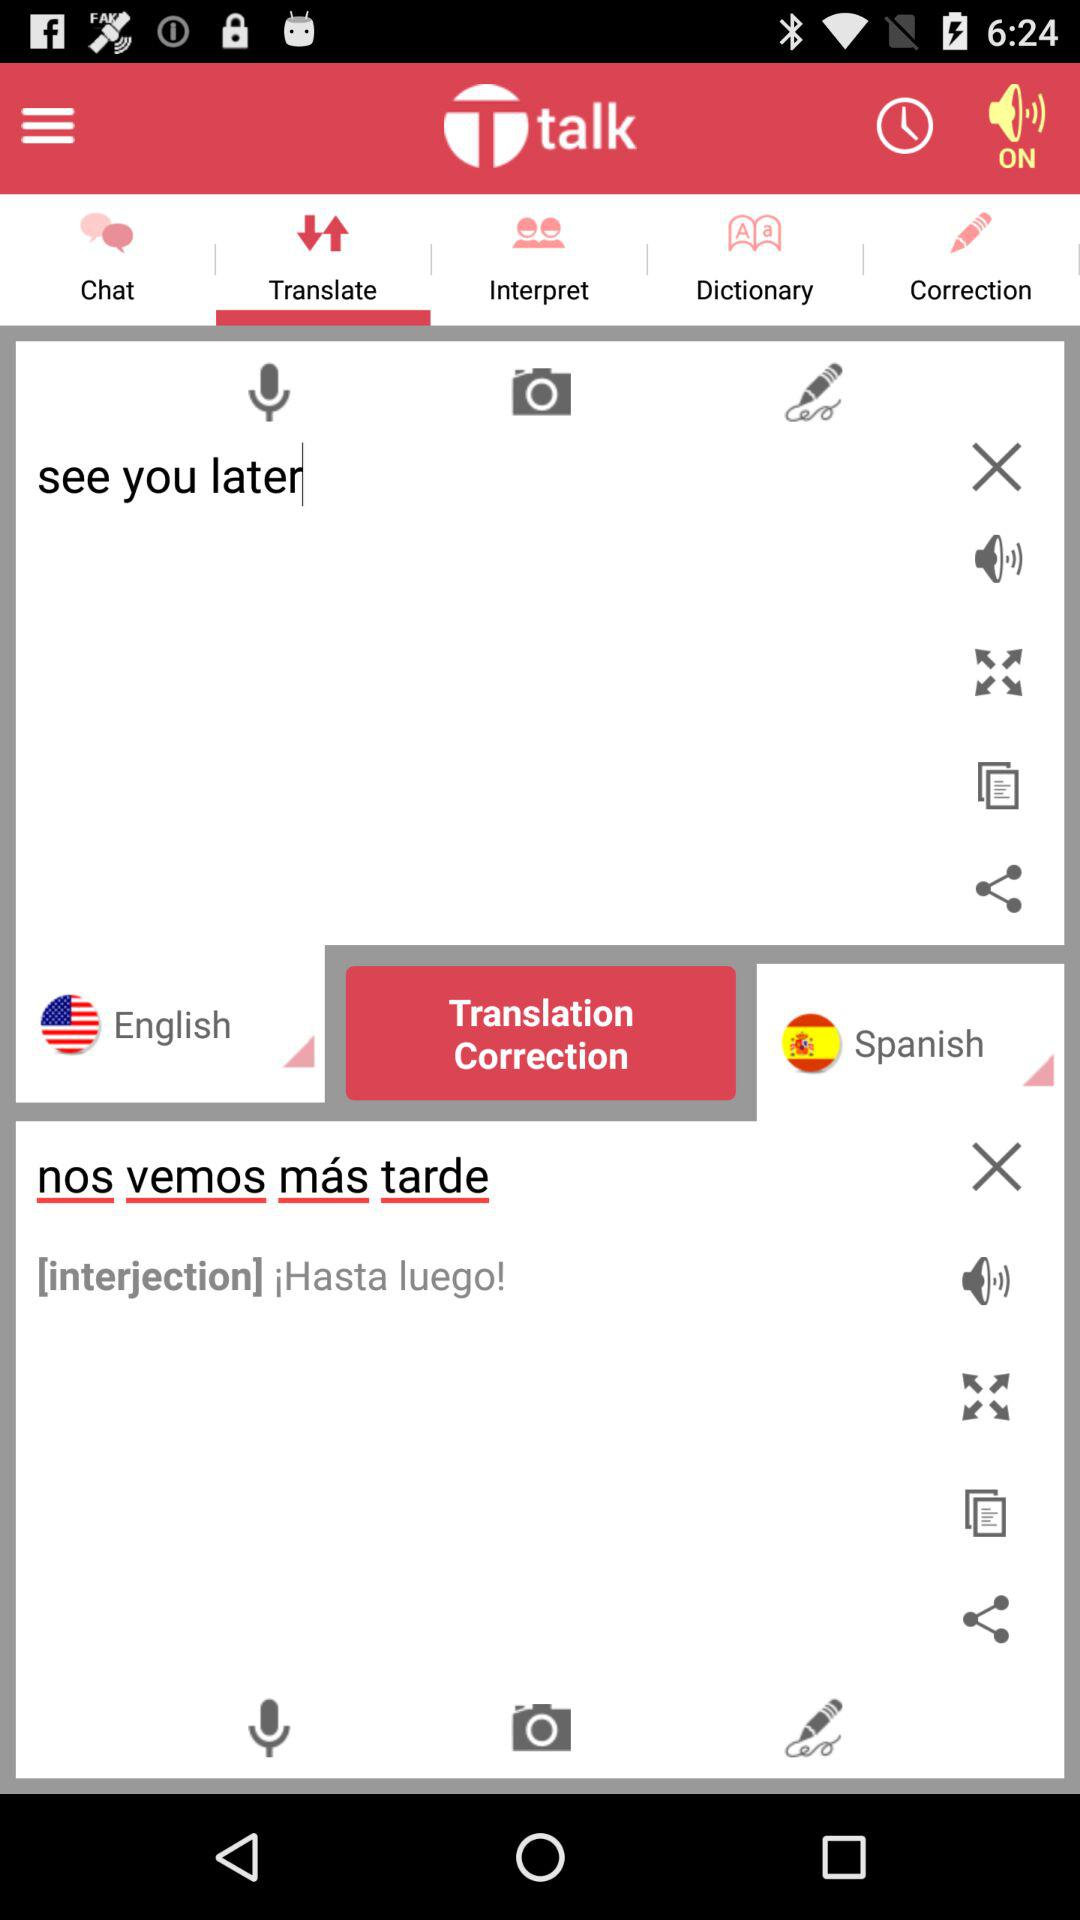What is the status of the "sound" option? The status is "on". 